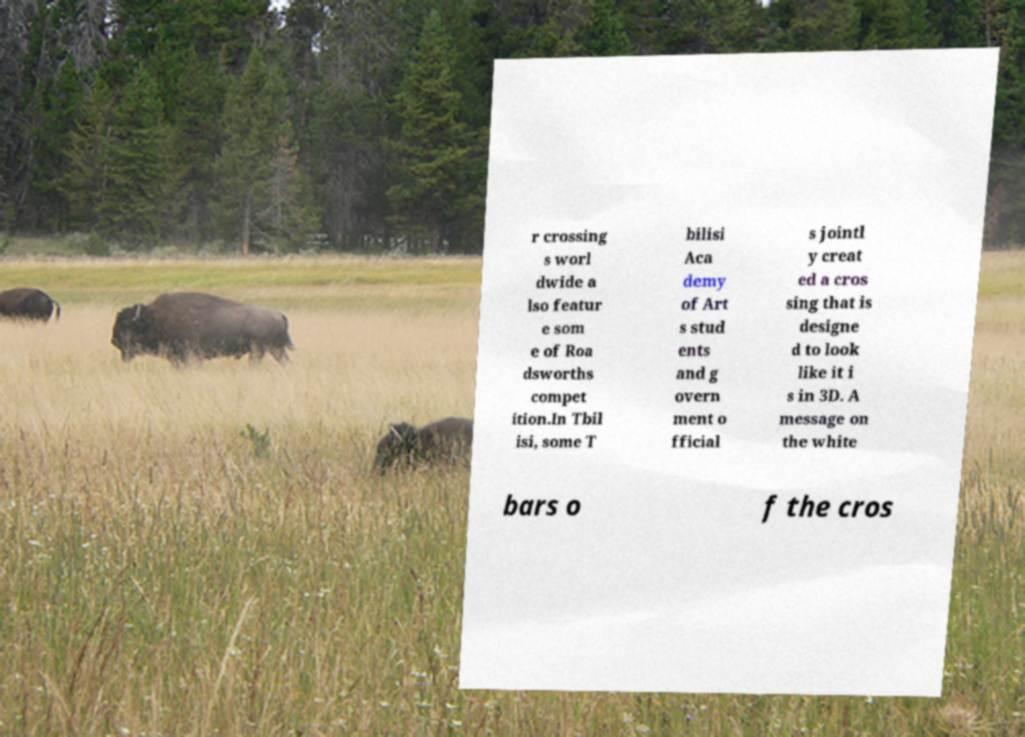There's text embedded in this image that I need extracted. Can you transcribe it verbatim? r crossing s worl dwide a lso featur e som e of Roa dsworths compet ition.In Tbil isi, some T bilisi Aca demy of Art s stud ents and g overn ment o fficial s jointl y creat ed a cros sing that is designe d to look like it i s in 3D. A message on the white bars o f the cros 